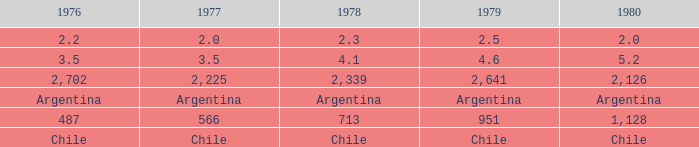What is 1977 when 1980 is chile? Chile. 